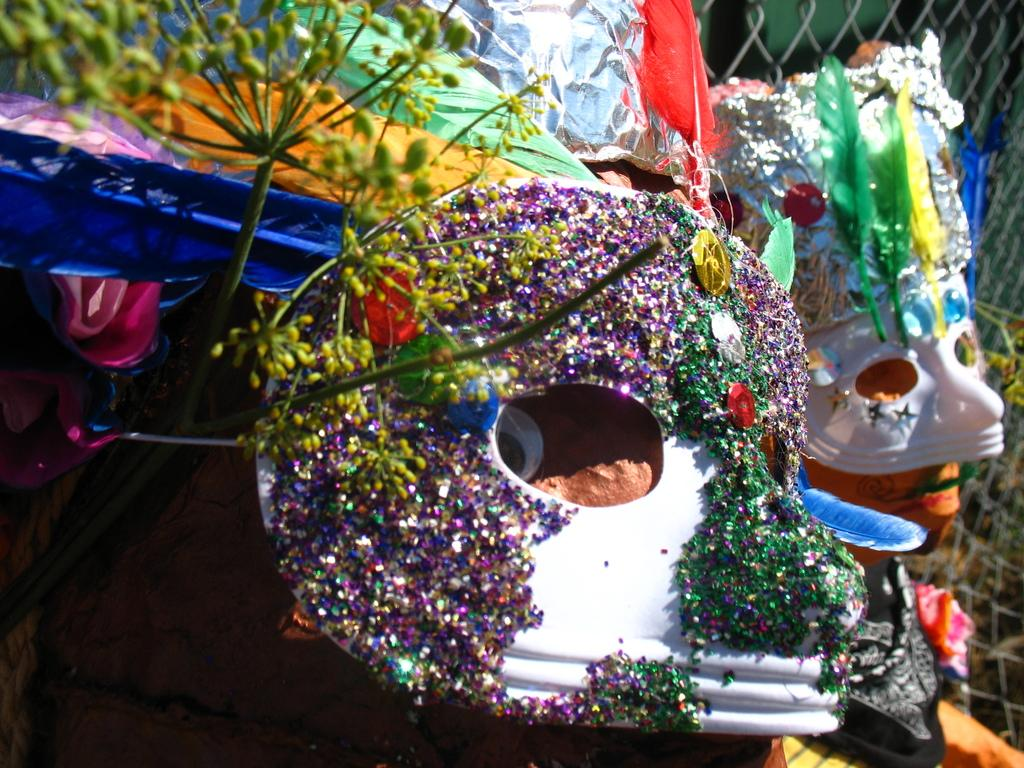What objects are present in the picture? There are masks in the picture. Can you describe the plant in the image? There is a plant on the left side of the image. What type of brick is used to build the slope in the image? There is no brick or slope present in the image; it features masks and a plant. 